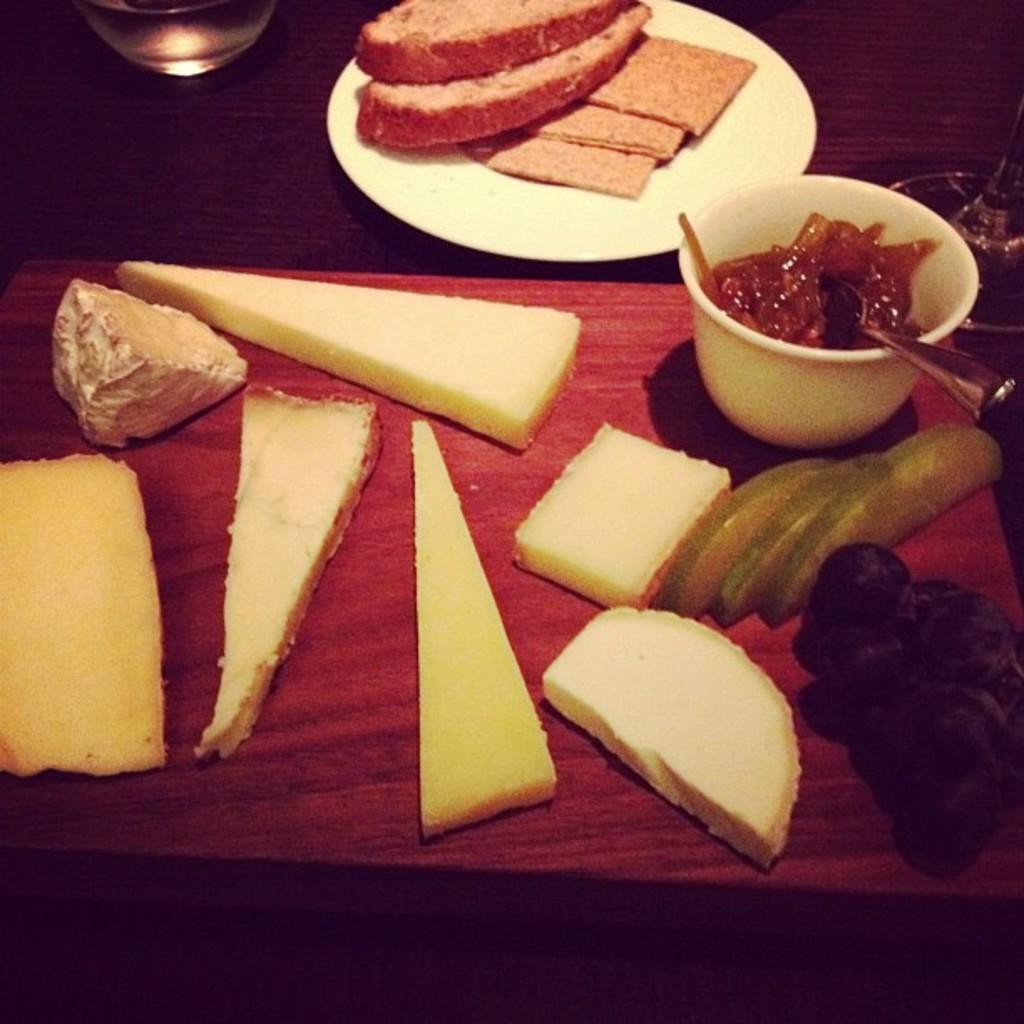Can you describe this image briefly? In the image there are some bread slices,fruits,jam and some other food items and a glass are placed on the table. 